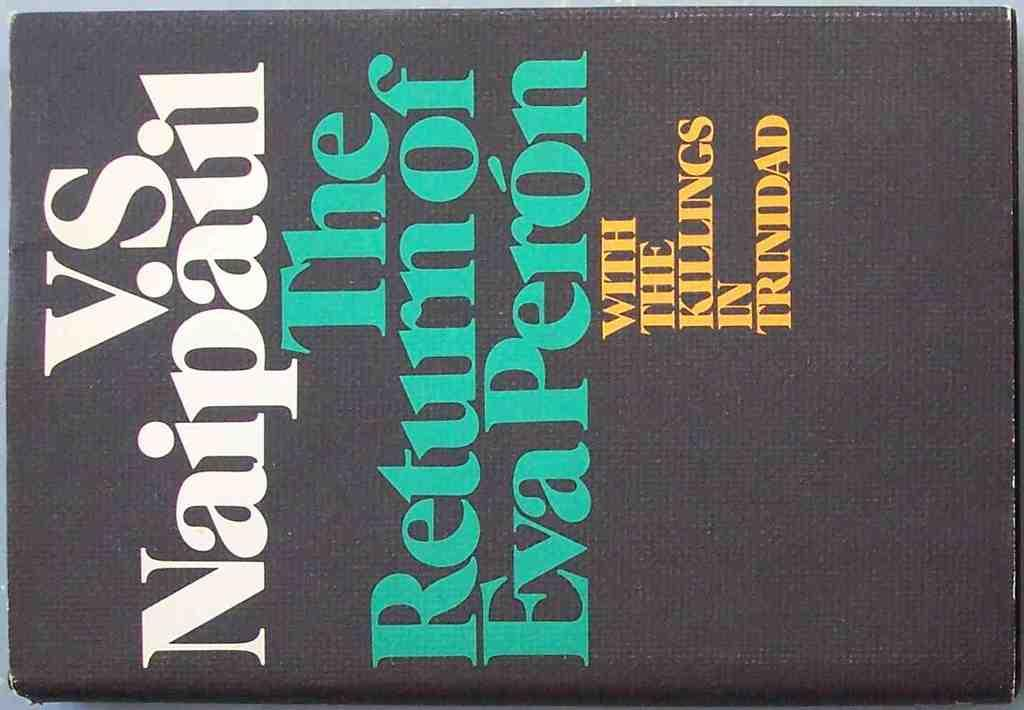<image>
Share a concise interpretation of the image provided. Black book titled "The Return of Eva Peron" in green words. 